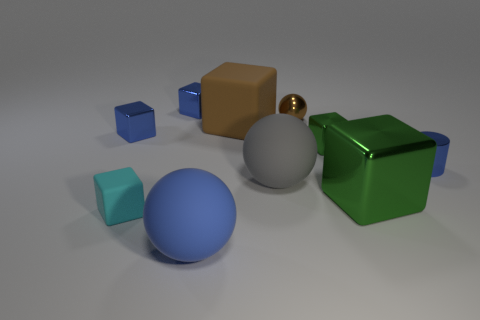Subtract all large green metallic cubes. How many cubes are left? 5 Subtract 1 cylinders. How many cylinders are left? 0 Subtract all blocks. How many objects are left? 4 Subtract all brown balls. How many balls are left? 2 Subtract all gray cylinders. Subtract all blue spheres. How many cylinders are left? 1 Subtract all tiny metal things. Subtract all big blue spheres. How many objects are left? 4 Add 8 large gray objects. How many large gray objects are left? 9 Add 4 cylinders. How many cylinders exist? 5 Subtract 0 red cylinders. How many objects are left? 10 Subtract all blue spheres. How many red cylinders are left? 0 